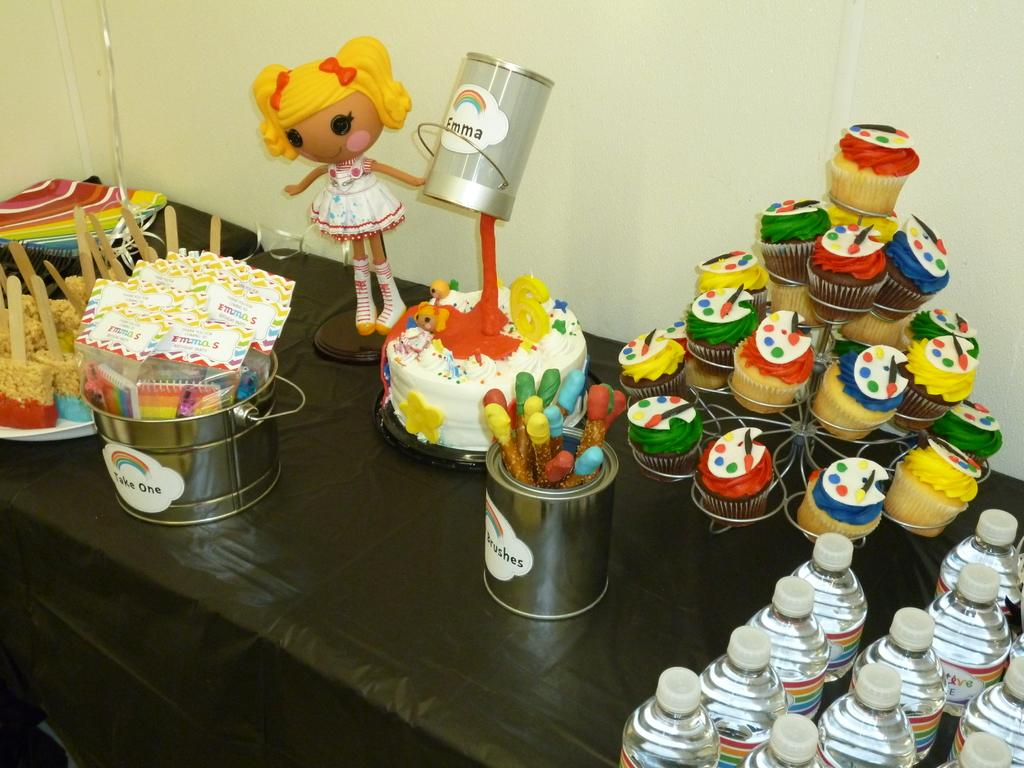What type of food items can be seen in the image? There are muffins and cakes in the image. What else is present on the table besides food items? There are bottles and a bucket on the table. Can you describe the location of these items? All these items are on a table. What type of linen is being used to cover the muffins in the image? There is no linen present in the image; the muffins are not covered. What arithmetic problem can be solved using the number of cakes and bottles in the image? There is no arithmetic problem to be solved, as the image does not provide numerical information about the number of cakes or bottles. 